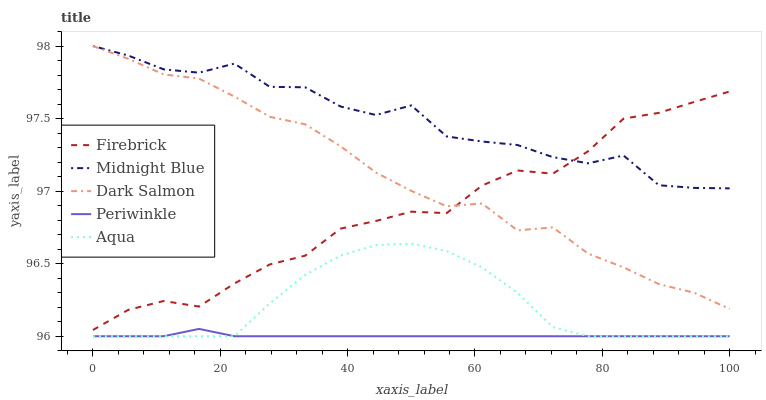Does Firebrick have the minimum area under the curve?
Answer yes or no. No. Does Firebrick have the maximum area under the curve?
Answer yes or no. No. Is Firebrick the smoothest?
Answer yes or no. No. Is Firebrick the roughest?
Answer yes or no. No. Does Firebrick have the lowest value?
Answer yes or no. No. Does Firebrick have the highest value?
Answer yes or no. No. Is Aqua less than Firebrick?
Answer yes or no. Yes. Is Firebrick greater than Periwinkle?
Answer yes or no. Yes. Does Aqua intersect Firebrick?
Answer yes or no. No. 